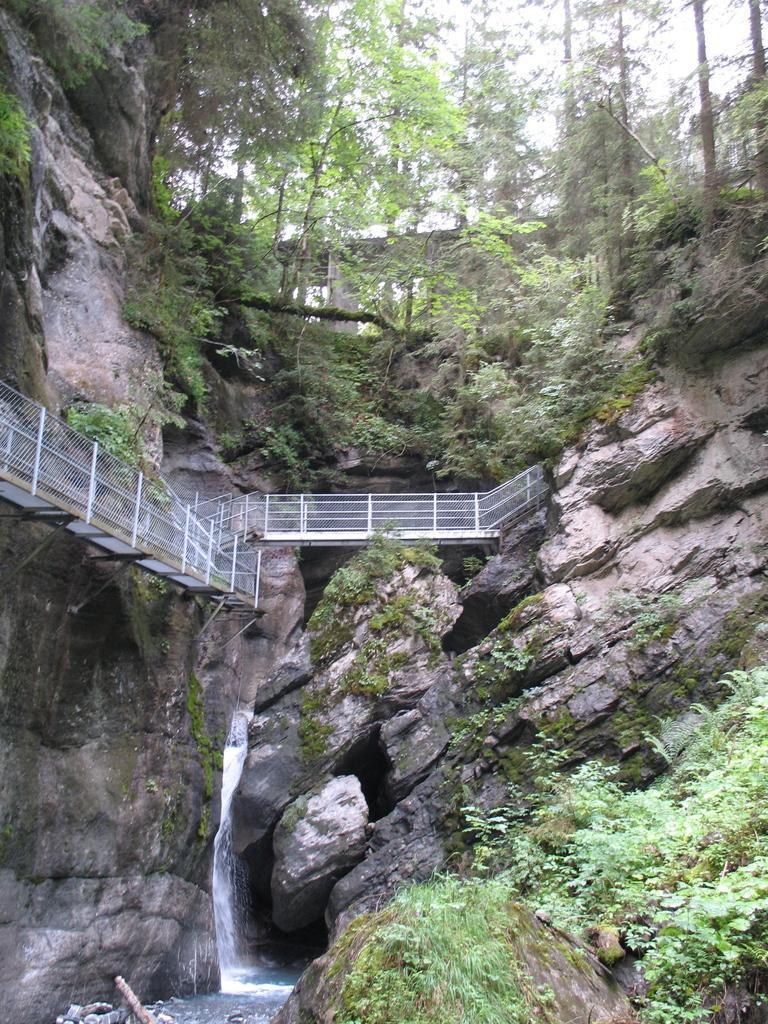Please provide a concise description of this image. In this image, we can see mountains, there is a bridge, we can see waterfall. There are some plants and trees. 